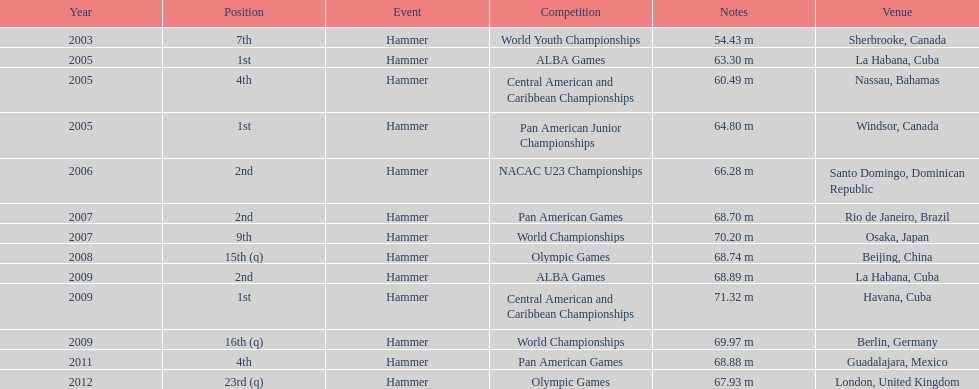Does arasay thondike have more/less than 4 1st place tournament finishes? Less. 